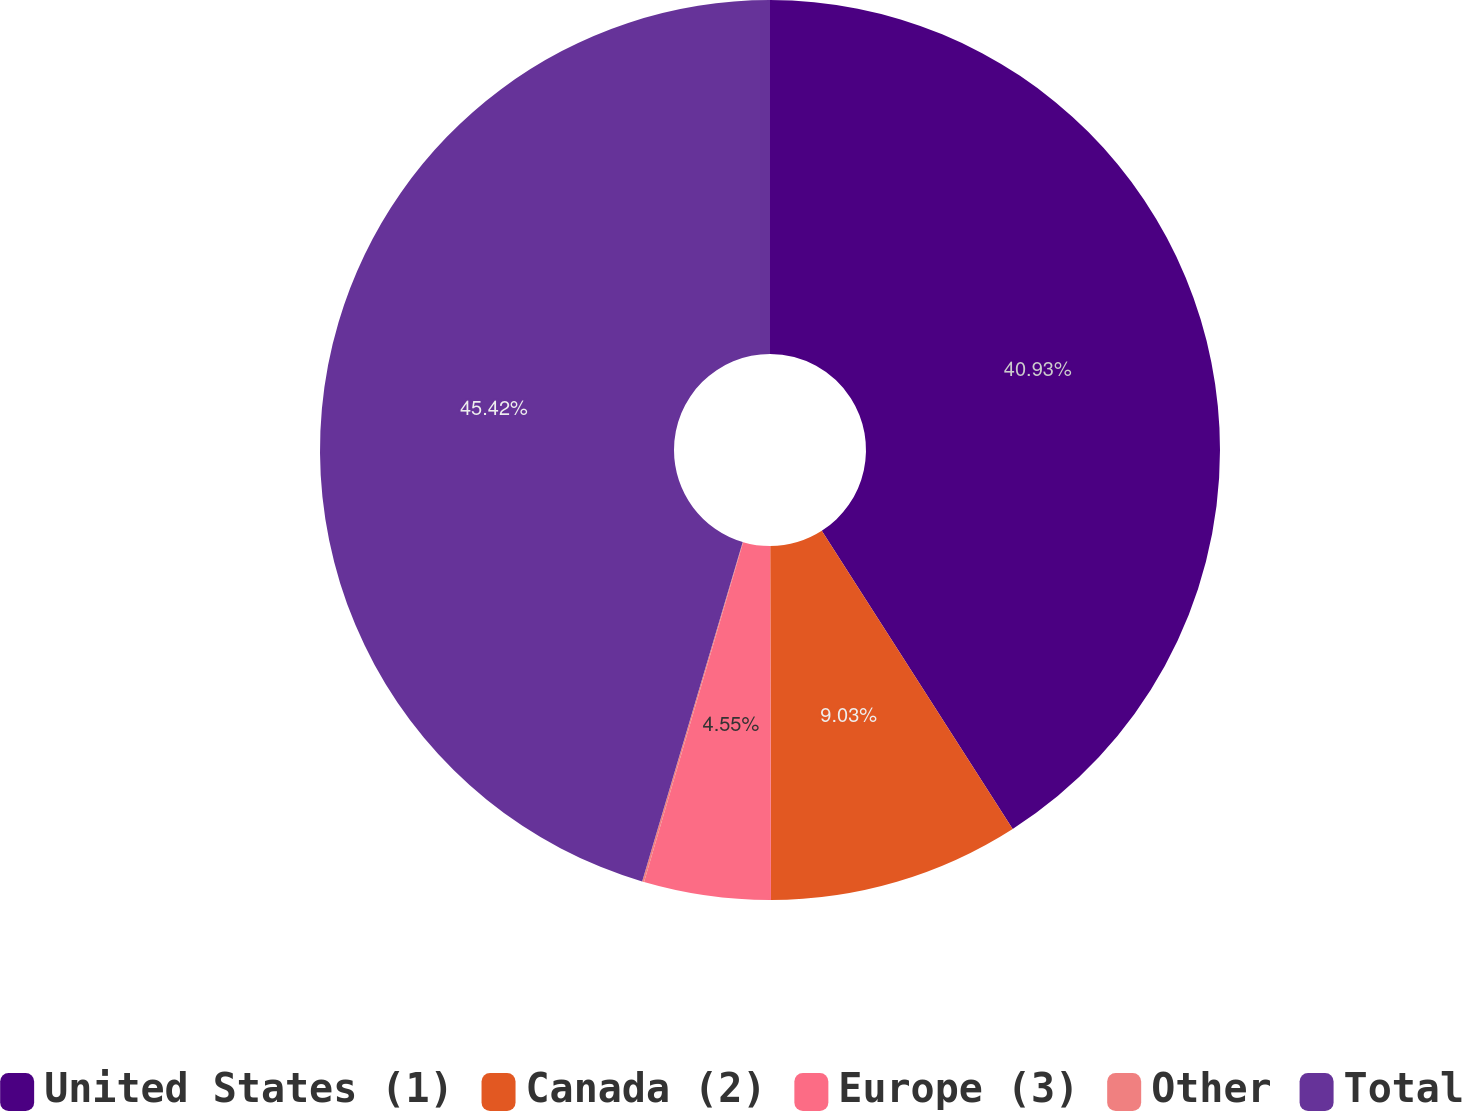Convert chart to OTSL. <chart><loc_0><loc_0><loc_500><loc_500><pie_chart><fcel>United States (1)<fcel>Canada (2)<fcel>Europe (3)<fcel>Other<fcel>Total<nl><fcel>40.93%<fcel>9.03%<fcel>4.55%<fcel>0.07%<fcel>45.41%<nl></chart> 